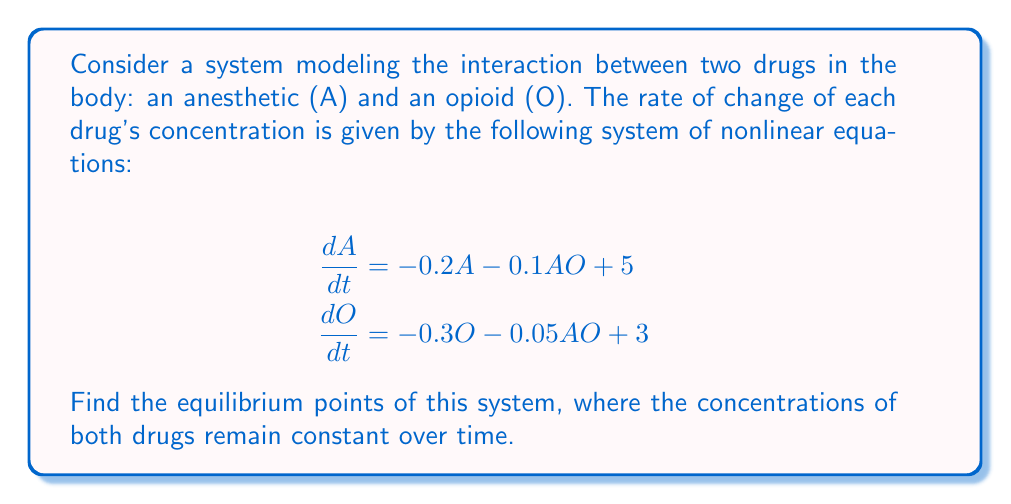Solve this math problem. To find the equilibrium points, we set both equations equal to zero and solve for A and O:

1) Set equations to zero:
   $$-0.2A - 0.1AO + 5 = 0$$
   $$-0.3O - 0.05AO + 3 = 0$$

2) Rearrange the first equation:
   $$-0.2A - 0.1AO = -5$$
   $$A(0.2 + 0.1O) = 5$$
   $$A = \frac{5}{0.2 + 0.1O}$$

3) Substitute this expression for A into the second equation:
   $$-0.3O - 0.05(\frac{5}{0.2 + 0.1O})O + 3 = 0$$

4) Multiply both sides by $(0.2 + 0.1O)$:
   $$-0.3O(0.2 + 0.1O) - 0.25O + 3(0.2 + 0.1O) = 0$$

5) Expand:
   $$-0.06O - 0.03O^2 - 0.25O + 0.6 + 0.3O = 0$$

6) Simplify:
   $$-0.03O^2 - 0.01O + 0.6 = 0$$

7) Multiply by -100 to eliminate decimals:
   $$3O^2 + O - 60 = 0$$

8) This is a quadratic equation. Solve using the quadratic formula:
   $$O = \frac{-1 \pm \sqrt{1^2 - 4(3)(-60)}}{2(3)}$$
   $$O = \frac{-1 \pm \sqrt{721}}{6}$$

9) This gives two solutions for O:
   $$O_1 \approx 4.31$$
   $$O_2 \approx -4.64$$

10) Since drug concentration cannot be negative, we discard the negative solution.

11) Substitute O ≈ 4.31 back into the equation for A:
    $$A = \frac{5}{0.2 + 0.1(4.31)} \approx 10.42$$

Therefore, the equilibrium point is approximately (A, O) ≈ (10.42, 4.31).
Answer: (A, O) ≈ (10.42, 4.31) 